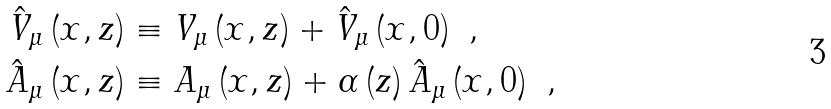Convert formula to latex. <formula><loc_0><loc_0><loc_500><loc_500>\hat { V } _ { \mu } \left ( x , z \right ) & \equiv V _ { \mu } \left ( x , z \right ) + \hat { V } _ { \mu } \left ( x , 0 \right ) \ , \\ \hat { A } _ { \mu } \left ( x , z \right ) & \equiv A _ { \mu } \left ( x , z \right ) + \alpha \left ( z \right ) \hat { A } _ { \mu } \left ( x , 0 \right ) \ ,</formula> 